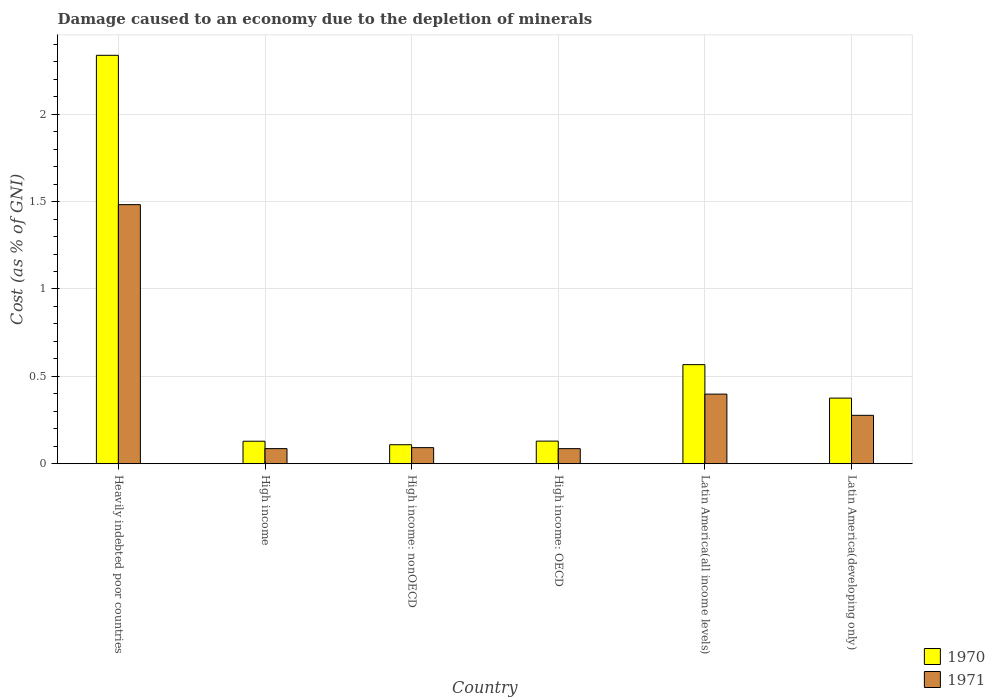How many different coloured bars are there?
Ensure brevity in your answer.  2. How many groups of bars are there?
Provide a short and direct response. 6. Are the number of bars per tick equal to the number of legend labels?
Your answer should be compact. Yes. How many bars are there on the 5th tick from the left?
Your response must be concise. 2. What is the label of the 1st group of bars from the left?
Give a very brief answer. Heavily indebted poor countries. In how many cases, is the number of bars for a given country not equal to the number of legend labels?
Provide a short and direct response. 0. What is the cost of damage caused due to the depletion of minerals in 1970 in Latin America(developing only)?
Your answer should be very brief. 0.38. Across all countries, what is the maximum cost of damage caused due to the depletion of minerals in 1971?
Offer a terse response. 1.48. Across all countries, what is the minimum cost of damage caused due to the depletion of minerals in 1971?
Offer a terse response. 0.09. In which country was the cost of damage caused due to the depletion of minerals in 1970 maximum?
Your answer should be very brief. Heavily indebted poor countries. In which country was the cost of damage caused due to the depletion of minerals in 1970 minimum?
Offer a very short reply. High income: nonOECD. What is the total cost of damage caused due to the depletion of minerals in 1971 in the graph?
Provide a short and direct response. 2.42. What is the difference between the cost of damage caused due to the depletion of minerals in 1971 in Latin America(all income levels) and that in Latin America(developing only)?
Your answer should be compact. 0.12. What is the difference between the cost of damage caused due to the depletion of minerals in 1971 in High income: OECD and the cost of damage caused due to the depletion of minerals in 1970 in High income: nonOECD?
Make the answer very short. -0.02. What is the average cost of damage caused due to the depletion of minerals in 1970 per country?
Make the answer very short. 0.61. What is the difference between the cost of damage caused due to the depletion of minerals of/in 1971 and cost of damage caused due to the depletion of minerals of/in 1970 in Latin America(developing only)?
Keep it short and to the point. -0.1. In how many countries, is the cost of damage caused due to the depletion of minerals in 1971 greater than 2.3 %?
Provide a succinct answer. 0. What is the ratio of the cost of damage caused due to the depletion of minerals in 1970 in High income to that in Latin America(developing only)?
Your response must be concise. 0.34. Is the cost of damage caused due to the depletion of minerals in 1971 in Heavily indebted poor countries less than that in Latin America(all income levels)?
Your answer should be very brief. No. What is the difference between the highest and the second highest cost of damage caused due to the depletion of minerals in 1970?
Offer a very short reply. -1.77. What is the difference between the highest and the lowest cost of damage caused due to the depletion of minerals in 1971?
Provide a short and direct response. 1.4. In how many countries, is the cost of damage caused due to the depletion of minerals in 1970 greater than the average cost of damage caused due to the depletion of minerals in 1970 taken over all countries?
Your response must be concise. 1. How many bars are there?
Your response must be concise. 12. Does the graph contain any zero values?
Your answer should be very brief. No. Does the graph contain grids?
Make the answer very short. Yes. How many legend labels are there?
Provide a succinct answer. 2. How are the legend labels stacked?
Your answer should be very brief. Vertical. What is the title of the graph?
Offer a terse response. Damage caused to an economy due to the depletion of minerals. What is the label or title of the X-axis?
Make the answer very short. Country. What is the label or title of the Y-axis?
Make the answer very short. Cost (as % of GNI). What is the Cost (as % of GNI) of 1970 in Heavily indebted poor countries?
Provide a short and direct response. 2.34. What is the Cost (as % of GNI) in 1971 in Heavily indebted poor countries?
Provide a succinct answer. 1.48. What is the Cost (as % of GNI) in 1970 in High income?
Make the answer very short. 0.13. What is the Cost (as % of GNI) of 1971 in High income?
Offer a very short reply. 0.09. What is the Cost (as % of GNI) of 1970 in High income: nonOECD?
Offer a very short reply. 0.11. What is the Cost (as % of GNI) of 1971 in High income: nonOECD?
Provide a short and direct response. 0.09. What is the Cost (as % of GNI) in 1970 in High income: OECD?
Give a very brief answer. 0.13. What is the Cost (as % of GNI) of 1971 in High income: OECD?
Offer a terse response. 0.09. What is the Cost (as % of GNI) of 1970 in Latin America(all income levels)?
Your answer should be very brief. 0.57. What is the Cost (as % of GNI) in 1971 in Latin America(all income levels)?
Your answer should be very brief. 0.4. What is the Cost (as % of GNI) of 1970 in Latin America(developing only)?
Provide a short and direct response. 0.38. What is the Cost (as % of GNI) in 1971 in Latin America(developing only)?
Ensure brevity in your answer.  0.28. Across all countries, what is the maximum Cost (as % of GNI) in 1970?
Offer a very short reply. 2.34. Across all countries, what is the maximum Cost (as % of GNI) of 1971?
Your answer should be compact. 1.48. Across all countries, what is the minimum Cost (as % of GNI) of 1970?
Give a very brief answer. 0.11. Across all countries, what is the minimum Cost (as % of GNI) of 1971?
Your answer should be compact. 0.09. What is the total Cost (as % of GNI) of 1970 in the graph?
Offer a very short reply. 3.65. What is the total Cost (as % of GNI) in 1971 in the graph?
Your answer should be compact. 2.42. What is the difference between the Cost (as % of GNI) in 1970 in Heavily indebted poor countries and that in High income?
Ensure brevity in your answer.  2.21. What is the difference between the Cost (as % of GNI) in 1971 in Heavily indebted poor countries and that in High income?
Your response must be concise. 1.4. What is the difference between the Cost (as % of GNI) in 1970 in Heavily indebted poor countries and that in High income: nonOECD?
Your answer should be compact. 2.23. What is the difference between the Cost (as % of GNI) in 1971 in Heavily indebted poor countries and that in High income: nonOECD?
Offer a terse response. 1.39. What is the difference between the Cost (as % of GNI) in 1970 in Heavily indebted poor countries and that in High income: OECD?
Provide a short and direct response. 2.21. What is the difference between the Cost (as % of GNI) in 1971 in Heavily indebted poor countries and that in High income: OECD?
Keep it short and to the point. 1.4. What is the difference between the Cost (as % of GNI) in 1970 in Heavily indebted poor countries and that in Latin America(all income levels)?
Offer a terse response. 1.77. What is the difference between the Cost (as % of GNI) of 1971 in Heavily indebted poor countries and that in Latin America(all income levels)?
Offer a terse response. 1.08. What is the difference between the Cost (as % of GNI) of 1970 in Heavily indebted poor countries and that in Latin America(developing only)?
Offer a very short reply. 1.96. What is the difference between the Cost (as % of GNI) in 1971 in Heavily indebted poor countries and that in Latin America(developing only)?
Ensure brevity in your answer.  1.21. What is the difference between the Cost (as % of GNI) in 1971 in High income and that in High income: nonOECD?
Your answer should be very brief. -0.01. What is the difference between the Cost (as % of GNI) in 1970 in High income and that in High income: OECD?
Ensure brevity in your answer.  -0. What is the difference between the Cost (as % of GNI) of 1970 in High income and that in Latin America(all income levels)?
Provide a short and direct response. -0.44. What is the difference between the Cost (as % of GNI) in 1971 in High income and that in Latin America(all income levels)?
Make the answer very short. -0.31. What is the difference between the Cost (as % of GNI) of 1970 in High income and that in Latin America(developing only)?
Provide a short and direct response. -0.25. What is the difference between the Cost (as % of GNI) in 1971 in High income and that in Latin America(developing only)?
Provide a short and direct response. -0.19. What is the difference between the Cost (as % of GNI) in 1970 in High income: nonOECD and that in High income: OECD?
Provide a short and direct response. -0.02. What is the difference between the Cost (as % of GNI) in 1971 in High income: nonOECD and that in High income: OECD?
Make the answer very short. 0.01. What is the difference between the Cost (as % of GNI) in 1970 in High income: nonOECD and that in Latin America(all income levels)?
Offer a terse response. -0.46. What is the difference between the Cost (as % of GNI) in 1971 in High income: nonOECD and that in Latin America(all income levels)?
Provide a succinct answer. -0.31. What is the difference between the Cost (as % of GNI) of 1970 in High income: nonOECD and that in Latin America(developing only)?
Offer a terse response. -0.27. What is the difference between the Cost (as % of GNI) of 1971 in High income: nonOECD and that in Latin America(developing only)?
Your response must be concise. -0.18. What is the difference between the Cost (as % of GNI) in 1970 in High income: OECD and that in Latin America(all income levels)?
Offer a very short reply. -0.44. What is the difference between the Cost (as % of GNI) in 1971 in High income: OECD and that in Latin America(all income levels)?
Provide a short and direct response. -0.31. What is the difference between the Cost (as % of GNI) in 1970 in High income: OECD and that in Latin America(developing only)?
Make the answer very short. -0.25. What is the difference between the Cost (as % of GNI) in 1971 in High income: OECD and that in Latin America(developing only)?
Offer a terse response. -0.19. What is the difference between the Cost (as % of GNI) in 1970 in Latin America(all income levels) and that in Latin America(developing only)?
Your answer should be compact. 0.19. What is the difference between the Cost (as % of GNI) of 1971 in Latin America(all income levels) and that in Latin America(developing only)?
Provide a succinct answer. 0.12. What is the difference between the Cost (as % of GNI) of 1970 in Heavily indebted poor countries and the Cost (as % of GNI) of 1971 in High income?
Offer a very short reply. 2.25. What is the difference between the Cost (as % of GNI) of 1970 in Heavily indebted poor countries and the Cost (as % of GNI) of 1971 in High income: nonOECD?
Your answer should be very brief. 2.25. What is the difference between the Cost (as % of GNI) in 1970 in Heavily indebted poor countries and the Cost (as % of GNI) in 1971 in High income: OECD?
Give a very brief answer. 2.25. What is the difference between the Cost (as % of GNI) of 1970 in Heavily indebted poor countries and the Cost (as % of GNI) of 1971 in Latin America(all income levels)?
Make the answer very short. 1.94. What is the difference between the Cost (as % of GNI) in 1970 in Heavily indebted poor countries and the Cost (as % of GNI) in 1971 in Latin America(developing only)?
Give a very brief answer. 2.06. What is the difference between the Cost (as % of GNI) of 1970 in High income and the Cost (as % of GNI) of 1971 in High income: nonOECD?
Offer a very short reply. 0.04. What is the difference between the Cost (as % of GNI) in 1970 in High income and the Cost (as % of GNI) in 1971 in High income: OECD?
Offer a very short reply. 0.04. What is the difference between the Cost (as % of GNI) of 1970 in High income and the Cost (as % of GNI) of 1971 in Latin America(all income levels)?
Make the answer very short. -0.27. What is the difference between the Cost (as % of GNI) of 1970 in High income and the Cost (as % of GNI) of 1971 in Latin America(developing only)?
Offer a very short reply. -0.15. What is the difference between the Cost (as % of GNI) in 1970 in High income: nonOECD and the Cost (as % of GNI) in 1971 in High income: OECD?
Give a very brief answer. 0.02. What is the difference between the Cost (as % of GNI) in 1970 in High income: nonOECD and the Cost (as % of GNI) in 1971 in Latin America(all income levels)?
Ensure brevity in your answer.  -0.29. What is the difference between the Cost (as % of GNI) of 1970 in High income: nonOECD and the Cost (as % of GNI) of 1971 in Latin America(developing only)?
Offer a very short reply. -0.17. What is the difference between the Cost (as % of GNI) in 1970 in High income: OECD and the Cost (as % of GNI) in 1971 in Latin America(all income levels)?
Ensure brevity in your answer.  -0.27. What is the difference between the Cost (as % of GNI) of 1970 in High income: OECD and the Cost (as % of GNI) of 1971 in Latin America(developing only)?
Offer a very short reply. -0.15. What is the difference between the Cost (as % of GNI) of 1970 in Latin America(all income levels) and the Cost (as % of GNI) of 1971 in Latin America(developing only)?
Offer a very short reply. 0.29. What is the average Cost (as % of GNI) of 1970 per country?
Keep it short and to the point. 0.61. What is the average Cost (as % of GNI) of 1971 per country?
Offer a terse response. 0.4. What is the difference between the Cost (as % of GNI) of 1970 and Cost (as % of GNI) of 1971 in Heavily indebted poor countries?
Provide a succinct answer. 0.85. What is the difference between the Cost (as % of GNI) in 1970 and Cost (as % of GNI) in 1971 in High income?
Offer a terse response. 0.04. What is the difference between the Cost (as % of GNI) in 1970 and Cost (as % of GNI) in 1971 in High income: nonOECD?
Offer a terse response. 0.02. What is the difference between the Cost (as % of GNI) of 1970 and Cost (as % of GNI) of 1971 in High income: OECD?
Offer a very short reply. 0.04. What is the difference between the Cost (as % of GNI) of 1970 and Cost (as % of GNI) of 1971 in Latin America(all income levels)?
Make the answer very short. 0.17. What is the difference between the Cost (as % of GNI) in 1970 and Cost (as % of GNI) in 1971 in Latin America(developing only)?
Provide a short and direct response. 0.1. What is the ratio of the Cost (as % of GNI) of 1970 in Heavily indebted poor countries to that in High income?
Your answer should be compact. 18.15. What is the ratio of the Cost (as % of GNI) in 1971 in Heavily indebted poor countries to that in High income?
Provide a succinct answer. 17.13. What is the ratio of the Cost (as % of GNI) of 1970 in Heavily indebted poor countries to that in High income: nonOECD?
Your answer should be compact. 21.48. What is the ratio of the Cost (as % of GNI) of 1971 in Heavily indebted poor countries to that in High income: nonOECD?
Give a very brief answer. 16.08. What is the ratio of the Cost (as % of GNI) in 1970 in Heavily indebted poor countries to that in High income: OECD?
Provide a succinct answer. 18.06. What is the ratio of the Cost (as % of GNI) of 1971 in Heavily indebted poor countries to that in High income: OECD?
Offer a very short reply. 17.17. What is the ratio of the Cost (as % of GNI) in 1970 in Heavily indebted poor countries to that in Latin America(all income levels)?
Ensure brevity in your answer.  4.12. What is the ratio of the Cost (as % of GNI) of 1971 in Heavily indebted poor countries to that in Latin America(all income levels)?
Your response must be concise. 3.72. What is the ratio of the Cost (as % of GNI) of 1970 in Heavily indebted poor countries to that in Latin America(developing only)?
Your response must be concise. 6.22. What is the ratio of the Cost (as % of GNI) of 1971 in Heavily indebted poor countries to that in Latin America(developing only)?
Make the answer very short. 5.35. What is the ratio of the Cost (as % of GNI) in 1970 in High income to that in High income: nonOECD?
Offer a very short reply. 1.18. What is the ratio of the Cost (as % of GNI) in 1971 in High income to that in High income: nonOECD?
Provide a succinct answer. 0.94. What is the ratio of the Cost (as % of GNI) in 1971 in High income to that in High income: OECD?
Your answer should be compact. 1. What is the ratio of the Cost (as % of GNI) in 1970 in High income to that in Latin America(all income levels)?
Your response must be concise. 0.23. What is the ratio of the Cost (as % of GNI) in 1971 in High income to that in Latin America(all income levels)?
Ensure brevity in your answer.  0.22. What is the ratio of the Cost (as % of GNI) in 1970 in High income to that in Latin America(developing only)?
Offer a very short reply. 0.34. What is the ratio of the Cost (as % of GNI) in 1971 in High income to that in Latin America(developing only)?
Provide a succinct answer. 0.31. What is the ratio of the Cost (as % of GNI) in 1970 in High income: nonOECD to that in High income: OECD?
Give a very brief answer. 0.84. What is the ratio of the Cost (as % of GNI) of 1971 in High income: nonOECD to that in High income: OECD?
Give a very brief answer. 1.07. What is the ratio of the Cost (as % of GNI) in 1970 in High income: nonOECD to that in Latin America(all income levels)?
Provide a succinct answer. 0.19. What is the ratio of the Cost (as % of GNI) in 1971 in High income: nonOECD to that in Latin America(all income levels)?
Keep it short and to the point. 0.23. What is the ratio of the Cost (as % of GNI) of 1970 in High income: nonOECD to that in Latin America(developing only)?
Offer a very short reply. 0.29. What is the ratio of the Cost (as % of GNI) of 1971 in High income: nonOECD to that in Latin America(developing only)?
Offer a very short reply. 0.33. What is the ratio of the Cost (as % of GNI) of 1970 in High income: OECD to that in Latin America(all income levels)?
Your answer should be very brief. 0.23. What is the ratio of the Cost (as % of GNI) in 1971 in High income: OECD to that in Latin America(all income levels)?
Ensure brevity in your answer.  0.22. What is the ratio of the Cost (as % of GNI) of 1970 in High income: OECD to that in Latin America(developing only)?
Offer a terse response. 0.34. What is the ratio of the Cost (as % of GNI) in 1971 in High income: OECD to that in Latin America(developing only)?
Your answer should be very brief. 0.31. What is the ratio of the Cost (as % of GNI) in 1970 in Latin America(all income levels) to that in Latin America(developing only)?
Make the answer very short. 1.51. What is the ratio of the Cost (as % of GNI) in 1971 in Latin America(all income levels) to that in Latin America(developing only)?
Keep it short and to the point. 1.44. What is the difference between the highest and the second highest Cost (as % of GNI) in 1970?
Provide a short and direct response. 1.77. What is the difference between the highest and the second highest Cost (as % of GNI) in 1971?
Make the answer very short. 1.08. What is the difference between the highest and the lowest Cost (as % of GNI) of 1970?
Offer a terse response. 2.23. What is the difference between the highest and the lowest Cost (as % of GNI) of 1971?
Offer a very short reply. 1.4. 